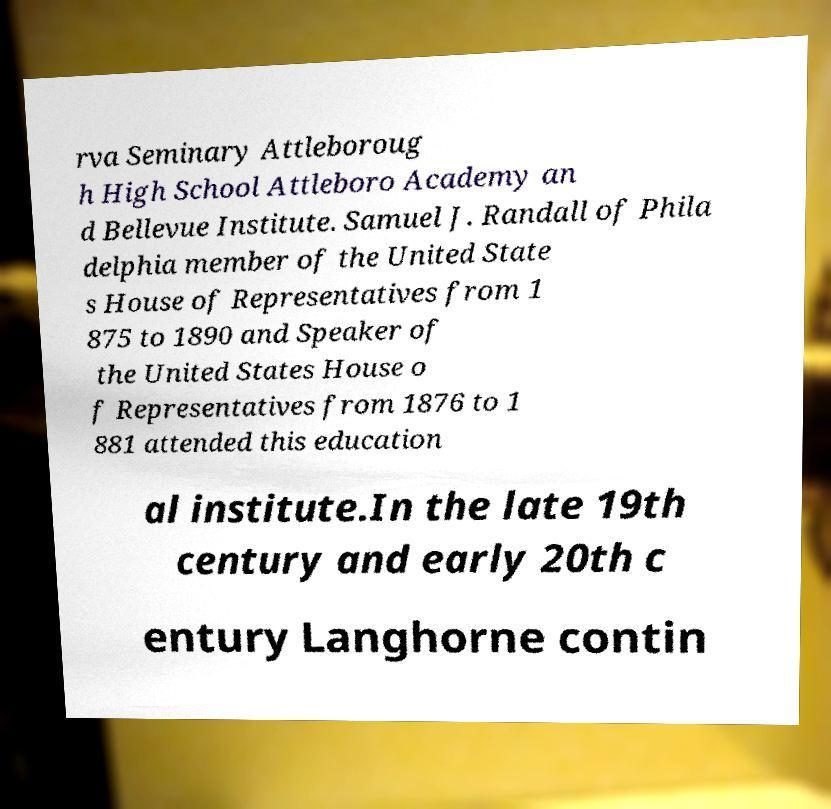Could you assist in decoding the text presented in this image and type it out clearly? rva Seminary Attleboroug h High School Attleboro Academy an d Bellevue Institute. Samuel J. Randall of Phila delphia member of the United State s House of Representatives from 1 875 to 1890 and Speaker of the United States House o f Representatives from 1876 to 1 881 attended this education al institute.In the late 19th century and early 20th c entury Langhorne contin 